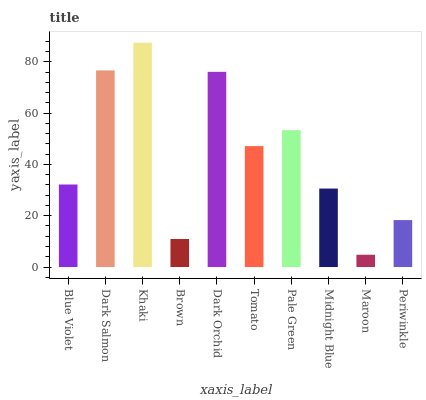Is Maroon the minimum?
Answer yes or no. Yes. Is Khaki the maximum?
Answer yes or no. Yes. Is Dark Salmon the minimum?
Answer yes or no. No. Is Dark Salmon the maximum?
Answer yes or no. No. Is Dark Salmon greater than Blue Violet?
Answer yes or no. Yes. Is Blue Violet less than Dark Salmon?
Answer yes or no. Yes. Is Blue Violet greater than Dark Salmon?
Answer yes or no. No. Is Dark Salmon less than Blue Violet?
Answer yes or no. No. Is Tomato the high median?
Answer yes or no. Yes. Is Blue Violet the low median?
Answer yes or no. Yes. Is Maroon the high median?
Answer yes or no. No. Is Khaki the low median?
Answer yes or no. No. 